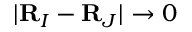<formula> <loc_0><loc_0><loc_500><loc_500>| { R } _ { I } - { R } _ { J } | \rightarrow 0</formula> 